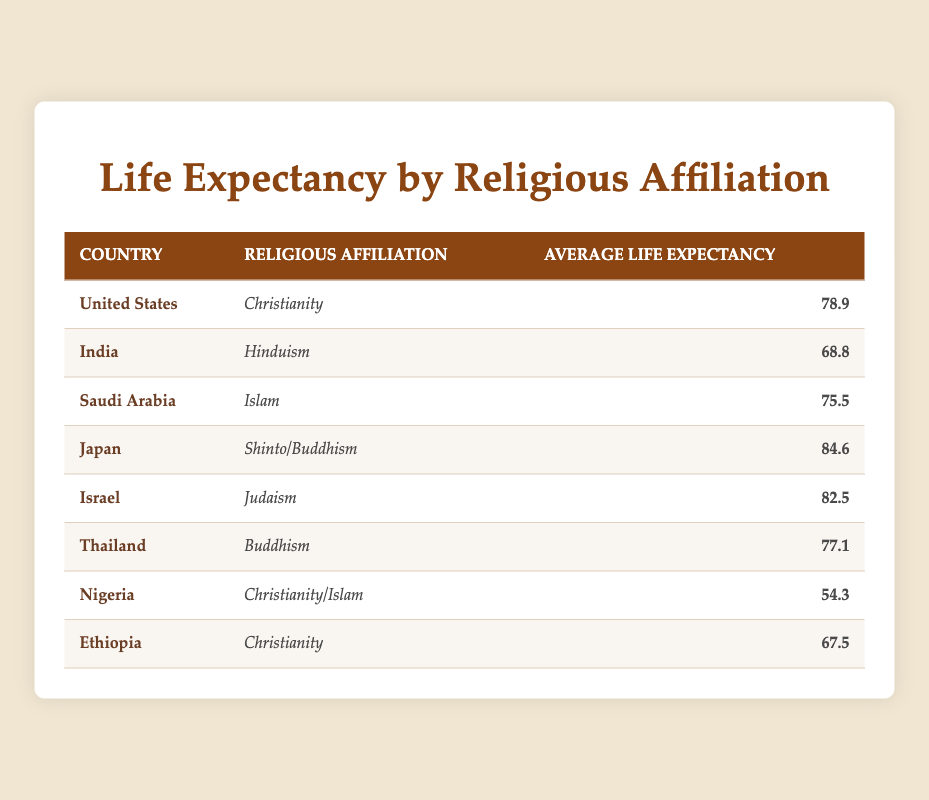What is the average life expectancy in Japan? The table shows that Japan has an average life expectancy of 84.6.
Answer: 84.6 Which country has the lowest average life expectancy? By scanning the table, Nigeria has the lowest average life expectancy, which is 54.3.
Answer: Nigeria What is the average life expectancy of countries with a Christian religious affiliation? The average life expectancies for the Christian-affiliated countries in the table are the United States (78.9), Ethiopia (67.5), and Nigeria (54.3). The sum is 78.9 + 67.5 + 54.3 = 200.7, and there are three countries, so the average is 200.7 / 3 = 66.9.
Answer: 66.9 Is the average life expectancy of Islamic countries higher than that of Hindu countries? Saudi Arabia, an Islamic country, has an average life expectancy of 75.5, while India, a Hindu country, has an average life expectancy of 68.8. Since 75.5 is greater than 68.8, the statement is true.
Answer: Yes How many countries have an average life expectancy above 80? By looking closely, the countries with an average life expectancy above 80 are Japan (84.6) and Israel (82.5), making a total of 2 countries.
Answer: 2 